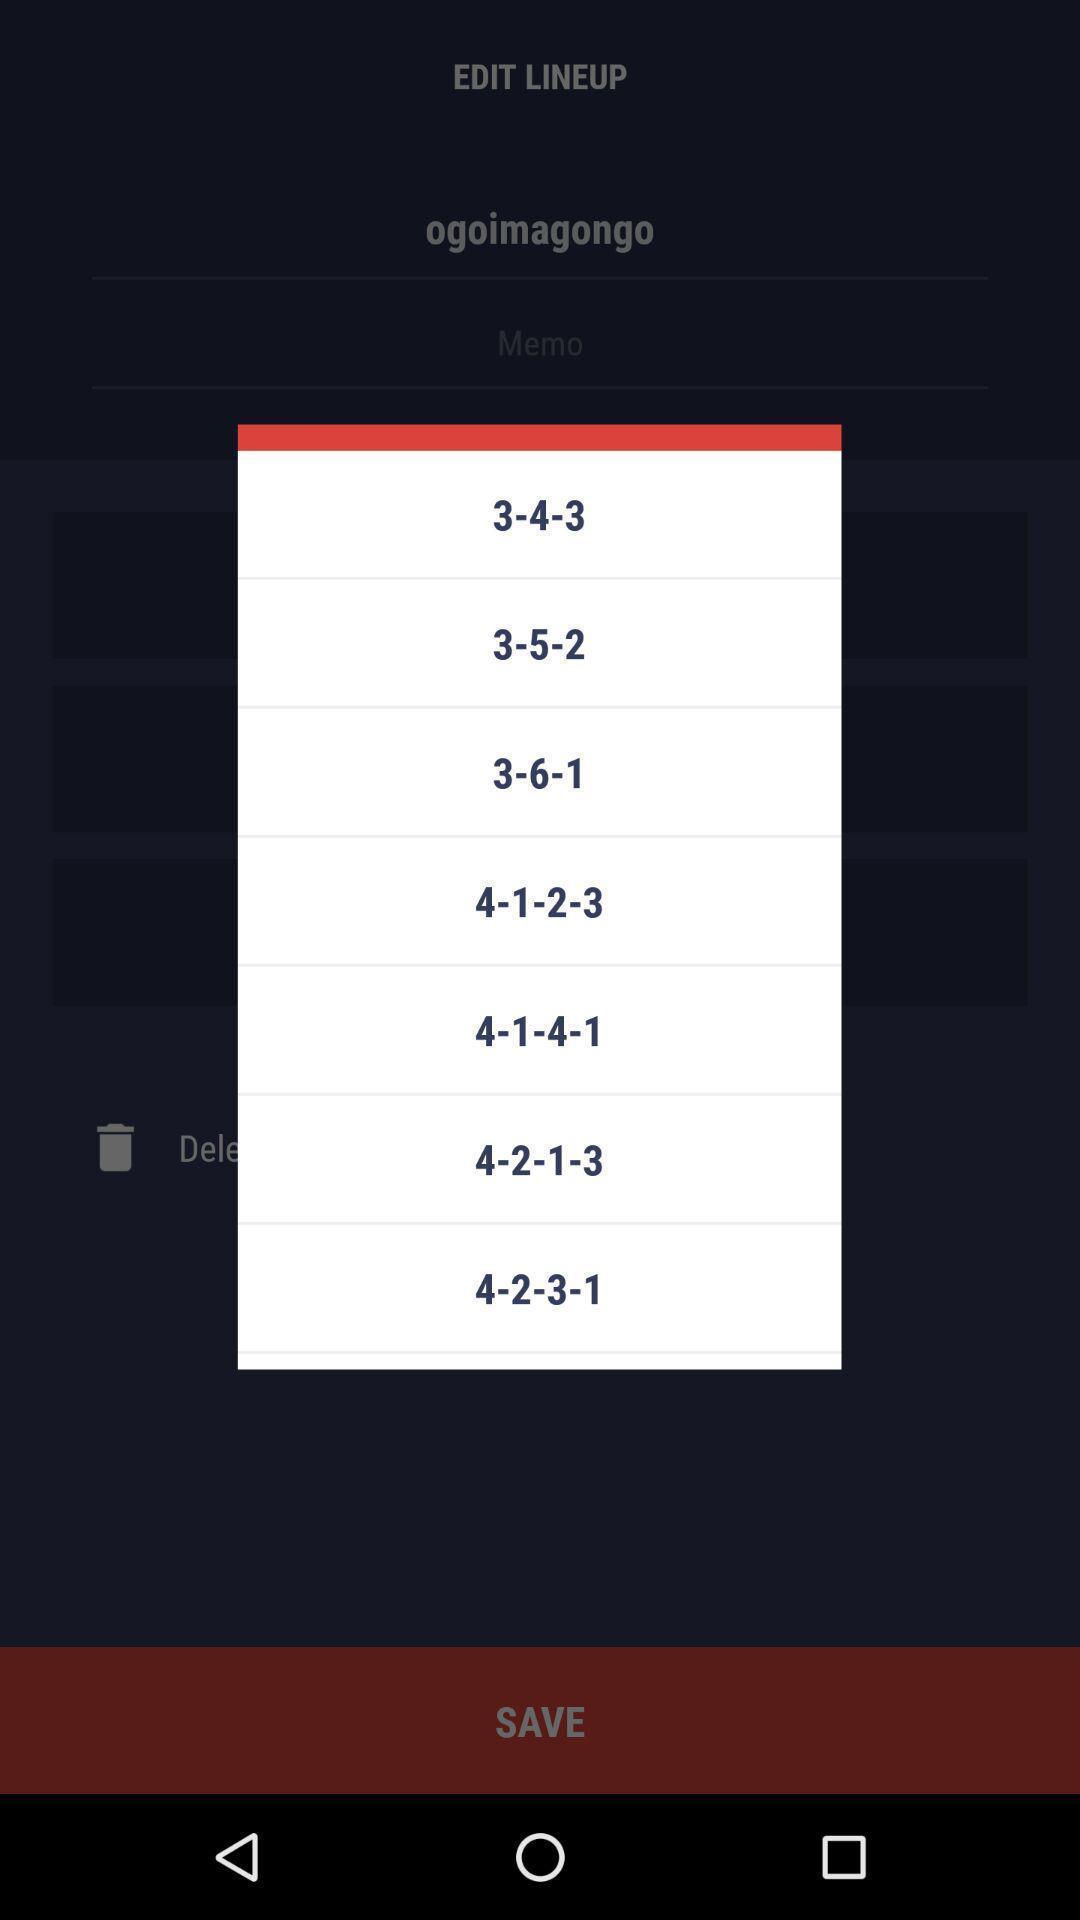Provide a detailed account of this screenshot. Pop-up showing score board in gaming app. 